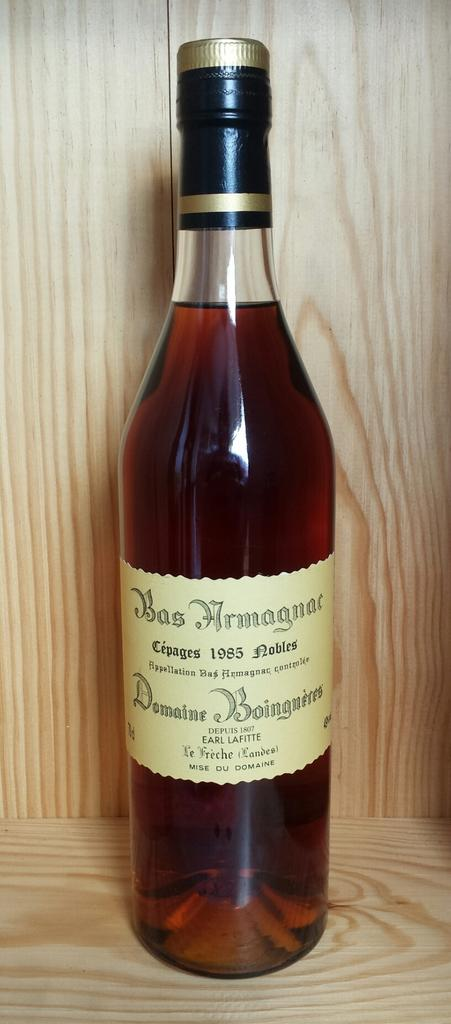What object can be seen in the image? There is a bottle in the image. Where is the bottle located? The bottle is on a table. What can be found on the label of the bottle? There are words on the label of the bottle. What colors are used for the cap of the bottle? The cap of the bottle is in gold and black color. How many police officers are visible in the image? There are no police officers present in the image; it only features a bottle on a table. What type of prison can be seen in the background of the image? There is no prison present in the image; it only features a bottle on a table. 